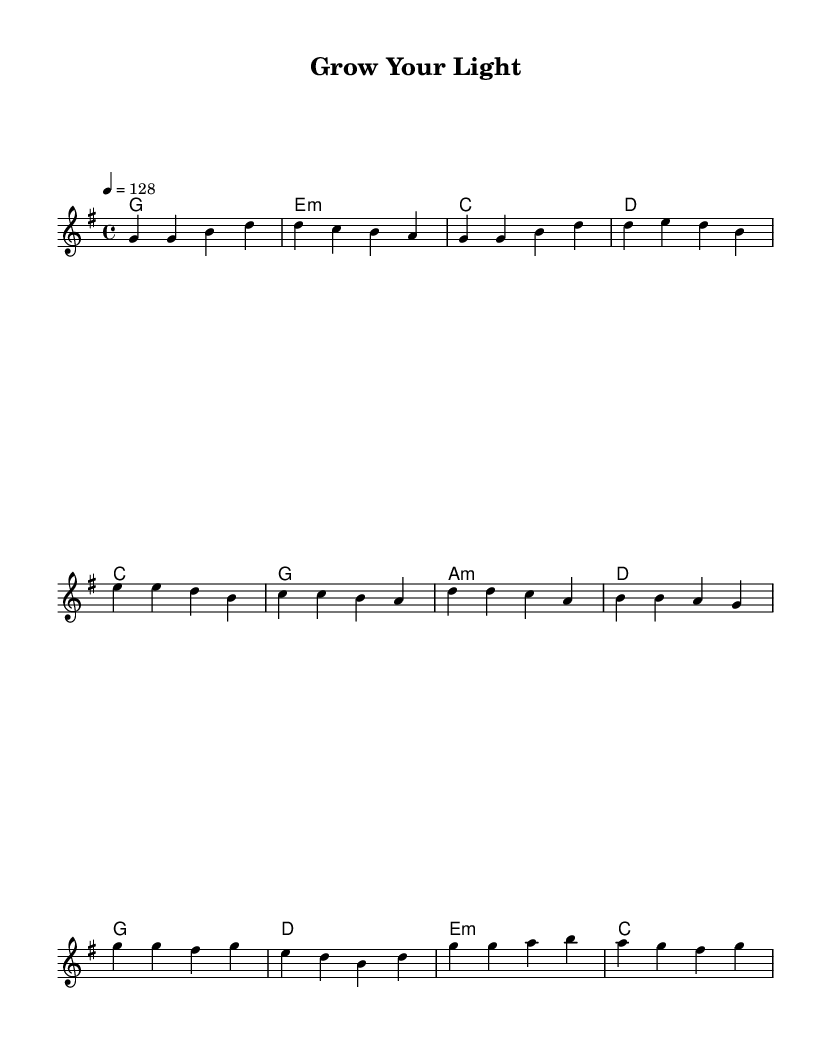What is the key signature of this music? The key signature indicates the tonality of the piece. In the provided music, the key signature shows one sharp (F#), which indicates that it is in G major.
Answer: G major What is the time signature of this piece? The time signature appears at the beginning of the music and indicates how many beats are in each measure. Here, it is notated as 4/4, meaning there are four beats in each measure, and the quarter note gets one beat.
Answer: 4/4 What is the tempo marking for this song? The tempo marking indicates the speed of the music. In the provided melody, it specifies "4 = 128,” meaning there are 128 beats per minute.
Answer: 128 What are the first two chords in the verse? The chords in the verse are indicated in the harmony section. The first two chords are G major and E minor, as seen directly in the chord notation.
Answer: G, E minor How many measures are in the chorus section? The chorus is made up of a series of measures that can be counted from the provided music. By looking at the melody line, there are four measures in the chorus section.
Answer: 4 What is the purpose of the pre-chorus in K-Pop songs? The pre-chorus typically builds anticipation and excitement leading into the chorus. In this piece, it serves to transition from the verse's themes of personal growth to the uplifting message of the chorus.
Answer: To build anticipation What is the main theme reflected in the lyrics of this anthem? The anthem is themed around personal growth and self-improvement, quite common in K-Pop, aiming to inspire listeners to pursue their dreams and become better versions of themselves.
Answer: Personal growth 